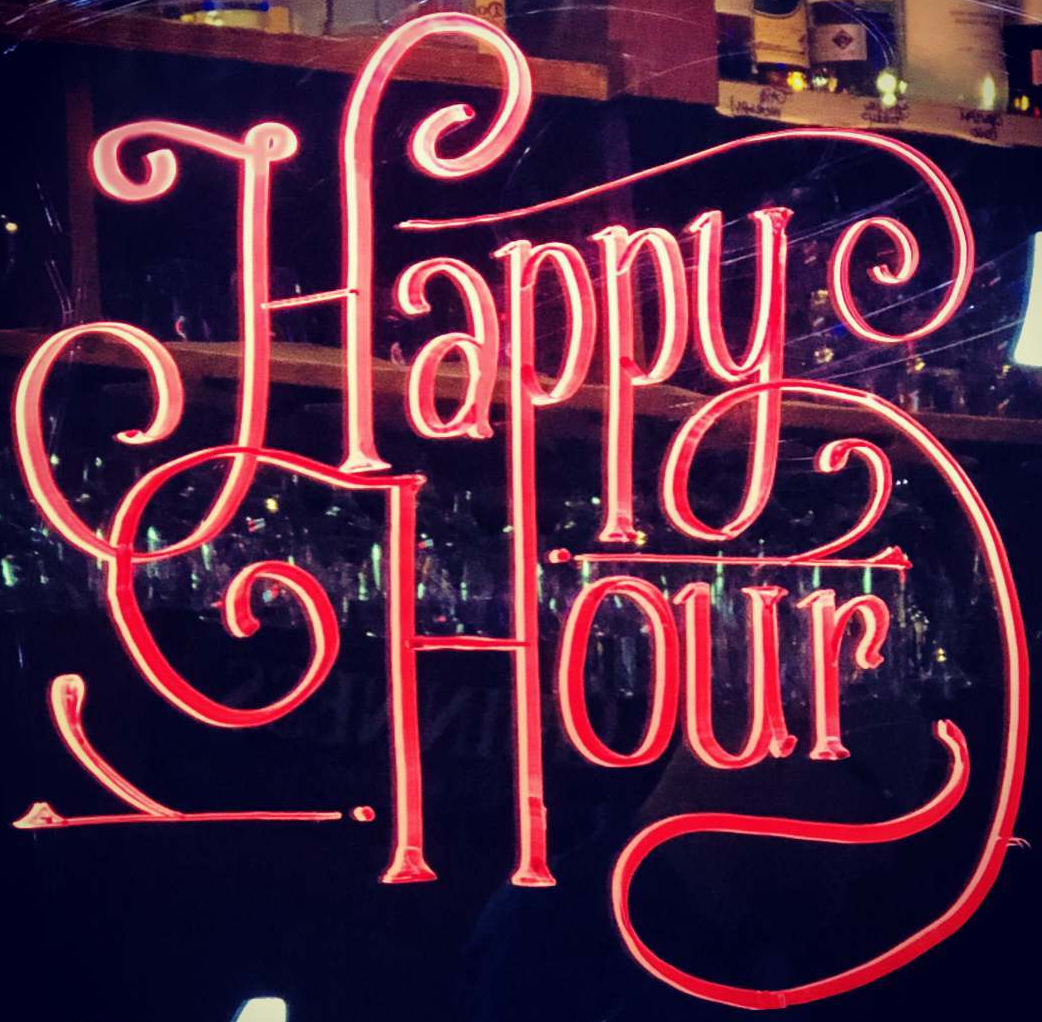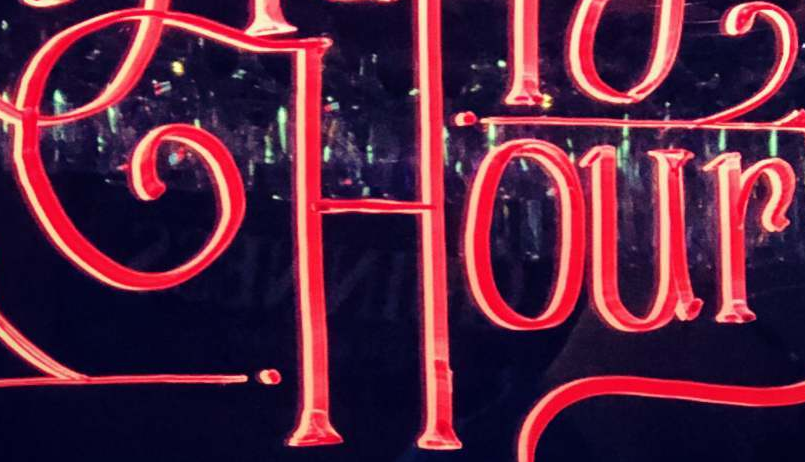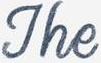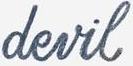What text appears in these images from left to right, separated by a semicolon? Happy; Hour; The; devil 